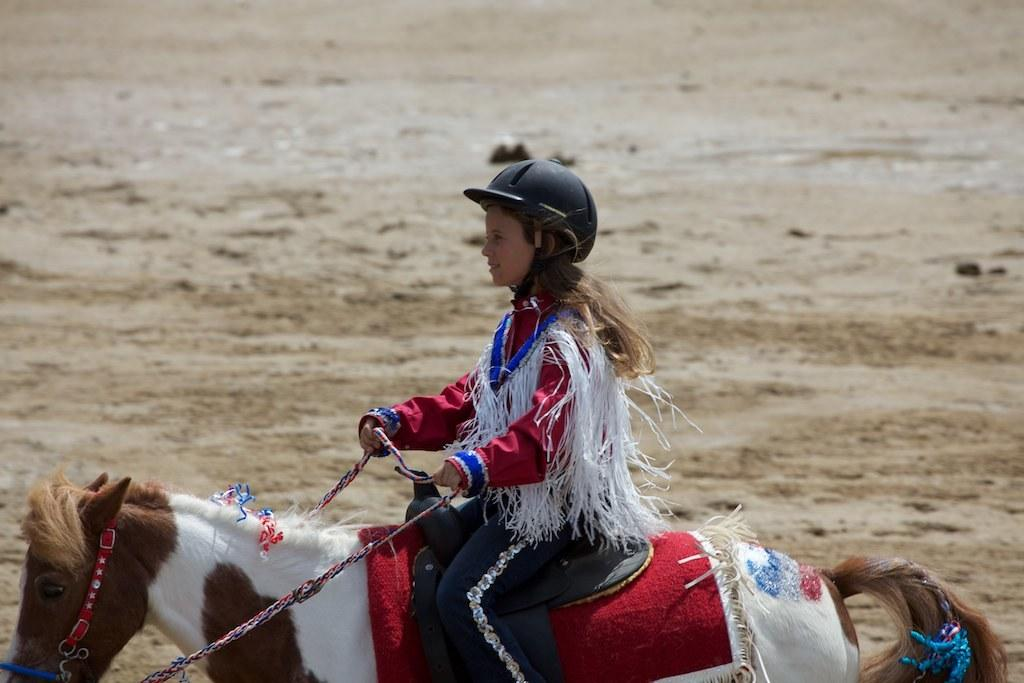Who is the main subject in the image? There is a girl in the image. What is the girl doing in the image? The girl is riding a horse. What type of wood can be seen in the image? There is no wood present in the image; it features a girl riding a horse. How many spiders can be seen on the horse in the image? There are no spiders present in the image. 